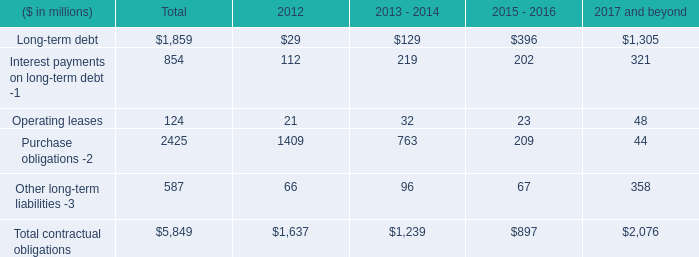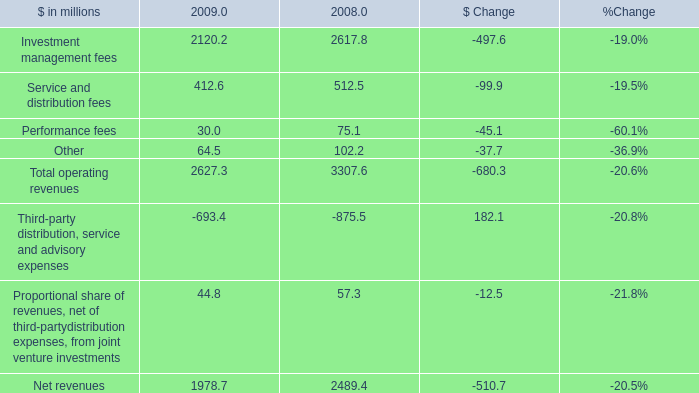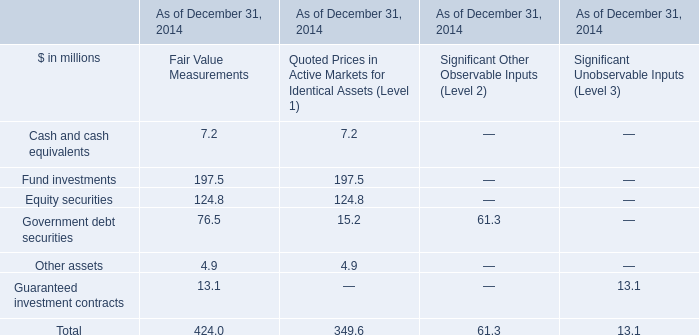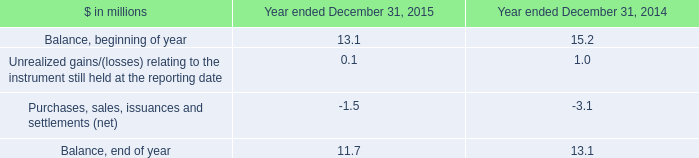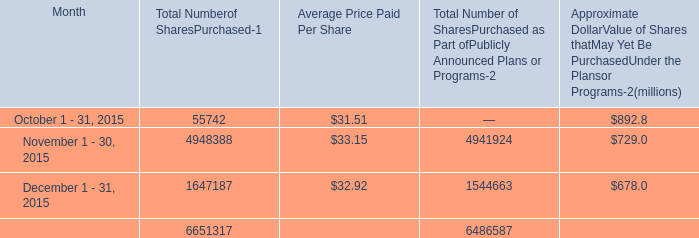Which section is Approximate DollarValue of Shares thatMay Yet Be PurchasedUnder the Plansor Programs the lowest? 
Answer: December 1 - 31, 2015. 